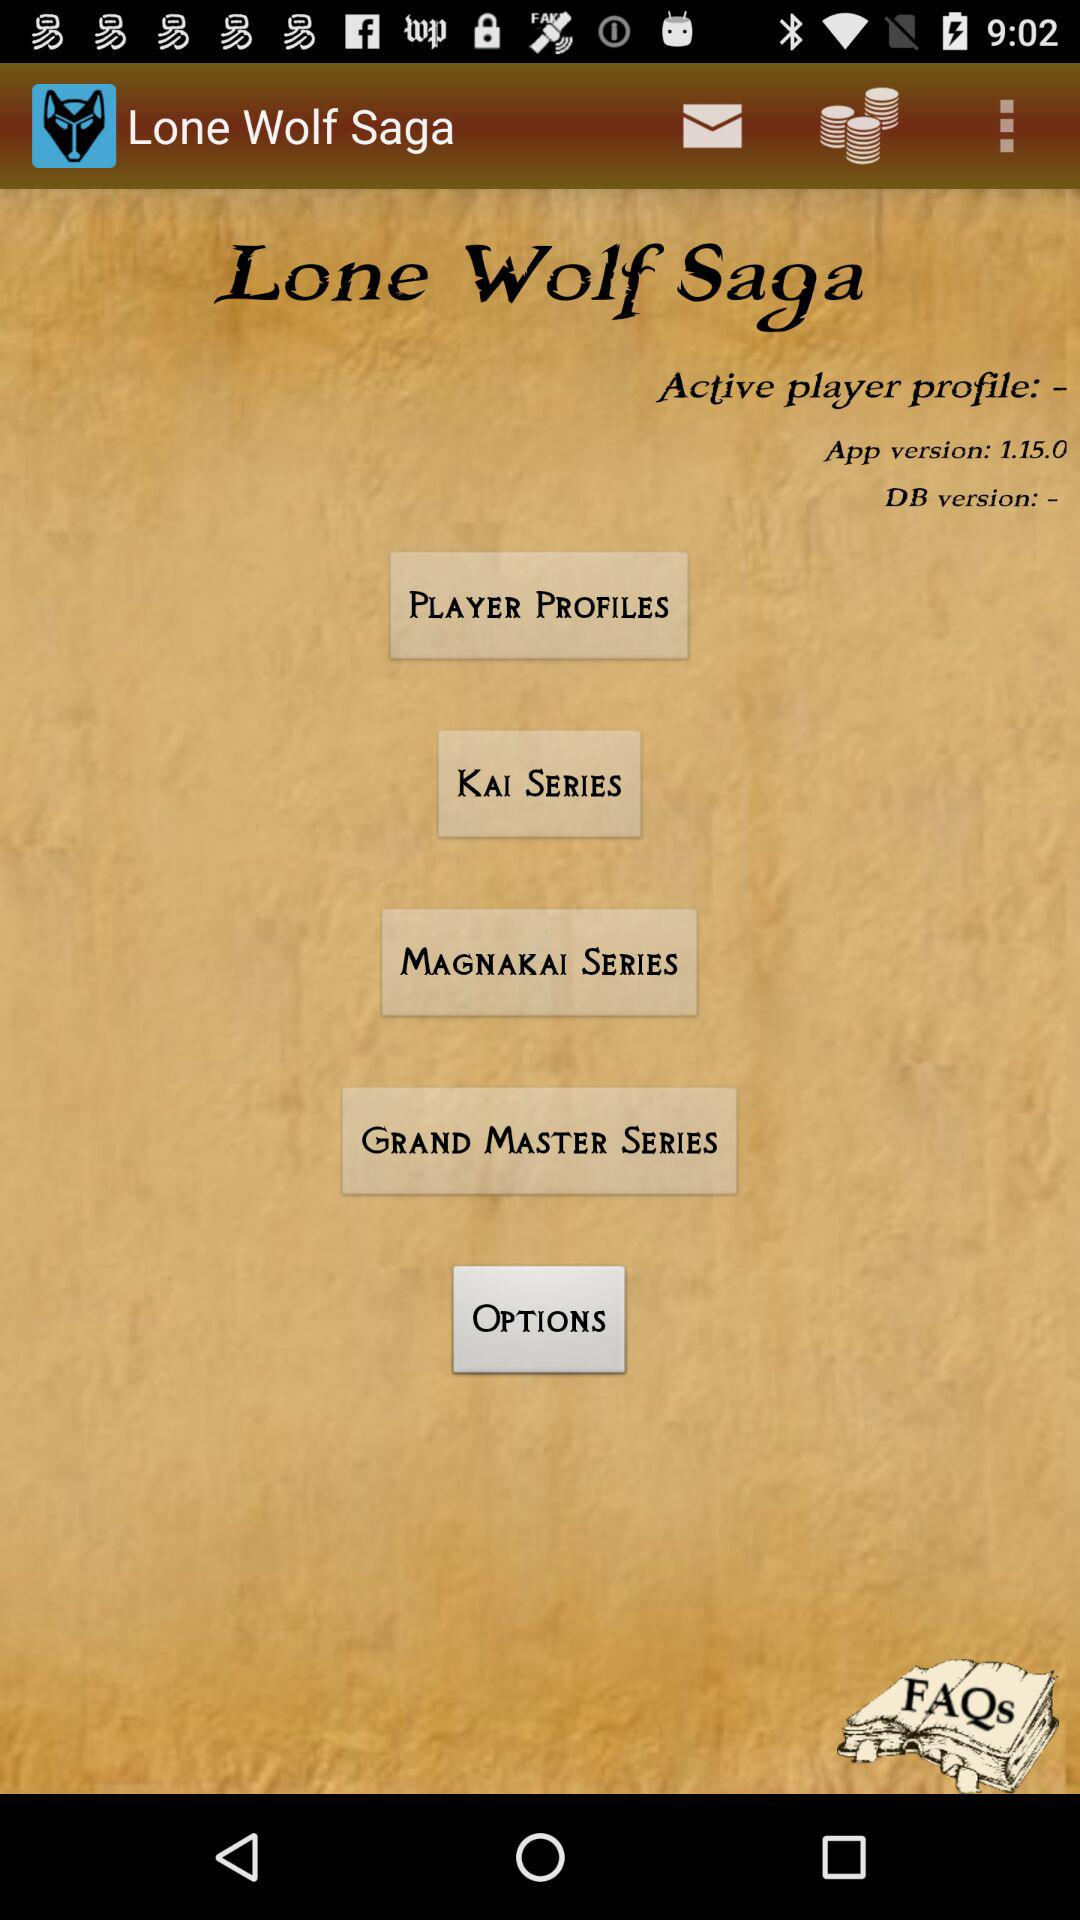What is the application name? The application name is "Lone Wolf Saga". 